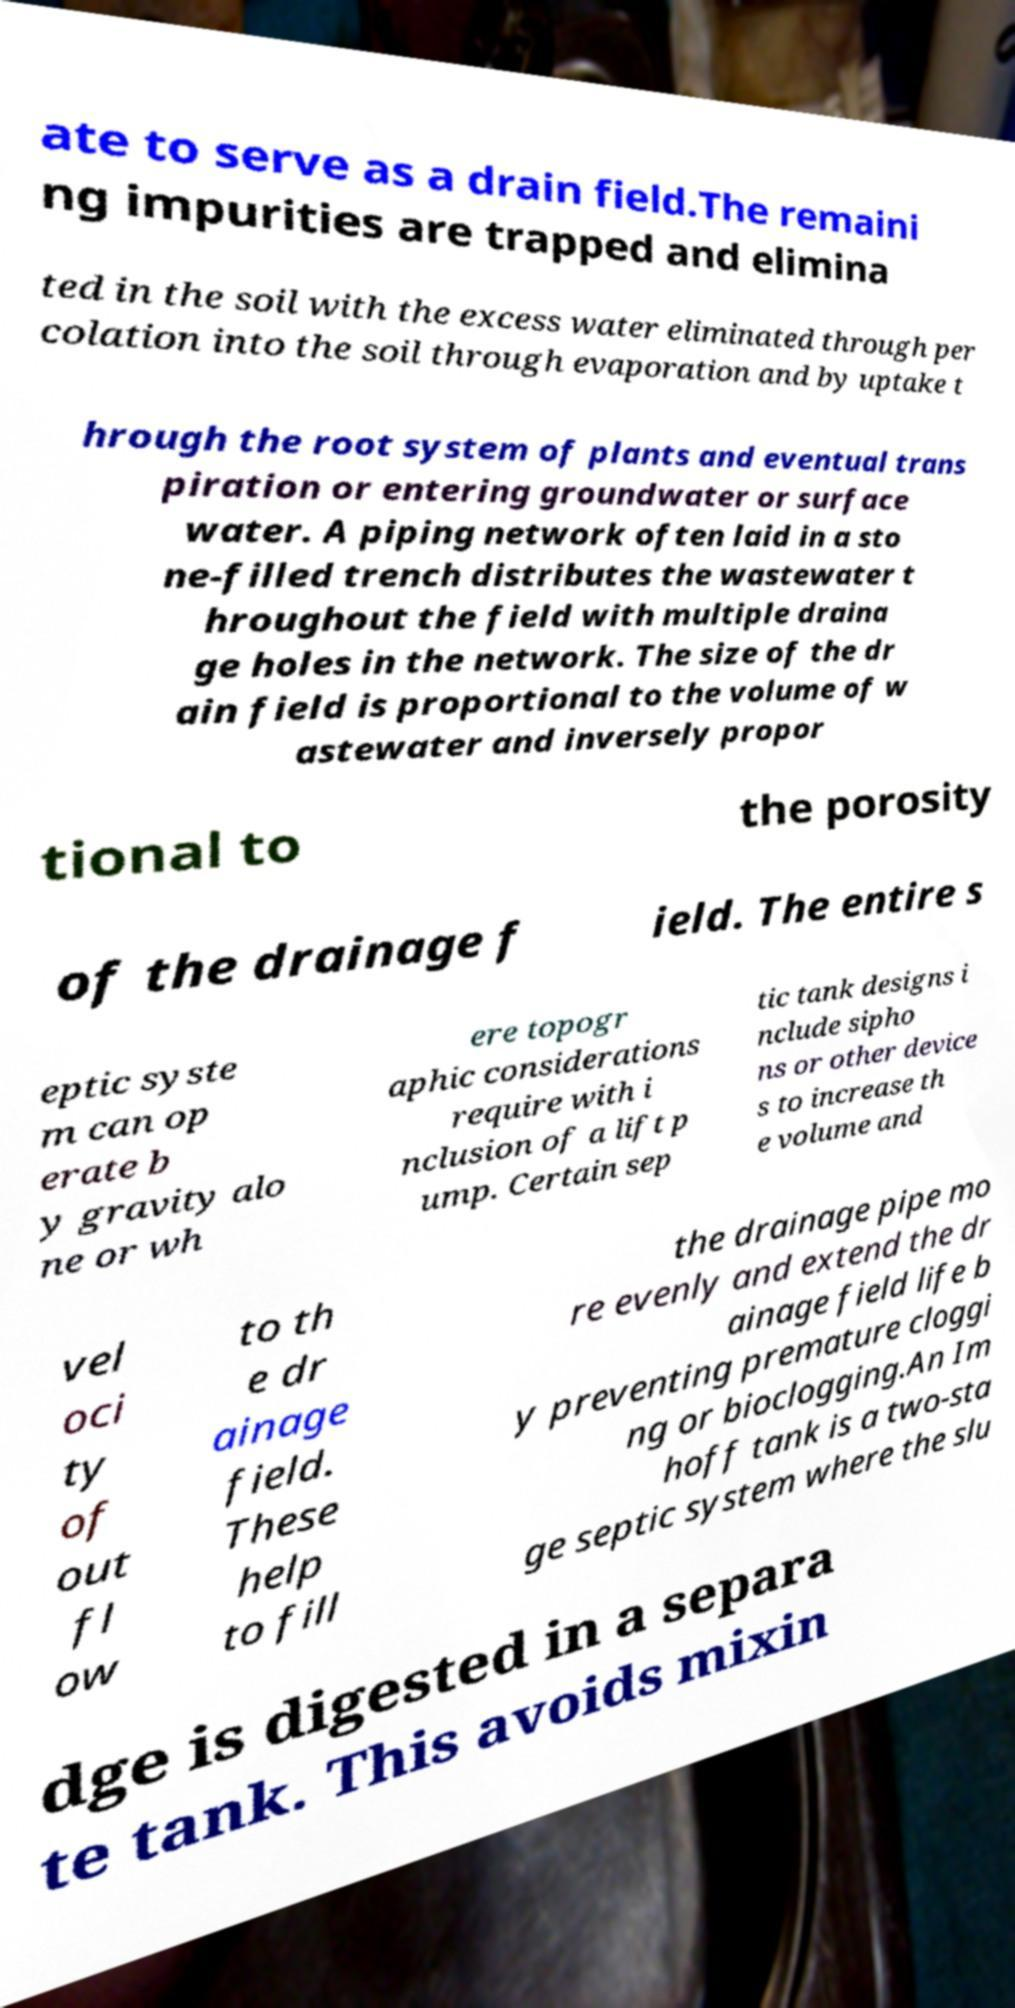There's text embedded in this image that I need extracted. Can you transcribe it verbatim? ate to serve as a drain field.The remaini ng impurities are trapped and elimina ted in the soil with the excess water eliminated through per colation into the soil through evaporation and by uptake t hrough the root system of plants and eventual trans piration or entering groundwater or surface water. A piping network often laid in a sto ne-filled trench distributes the wastewater t hroughout the field with multiple draina ge holes in the network. The size of the dr ain field is proportional to the volume of w astewater and inversely propor tional to the porosity of the drainage f ield. The entire s eptic syste m can op erate b y gravity alo ne or wh ere topogr aphic considerations require with i nclusion of a lift p ump. Certain sep tic tank designs i nclude sipho ns or other device s to increase th e volume and vel oci ty of out fl ow to th e dr ainage field. These help to fill the drainage pipe mo re evenly and extend the dr ainage field life b y preventing premature cloggi ng or bioclogging.An Im hoff tank is a two-sta ge septic system where the slu dge is digested in a separa te tank. This avoids mixin 